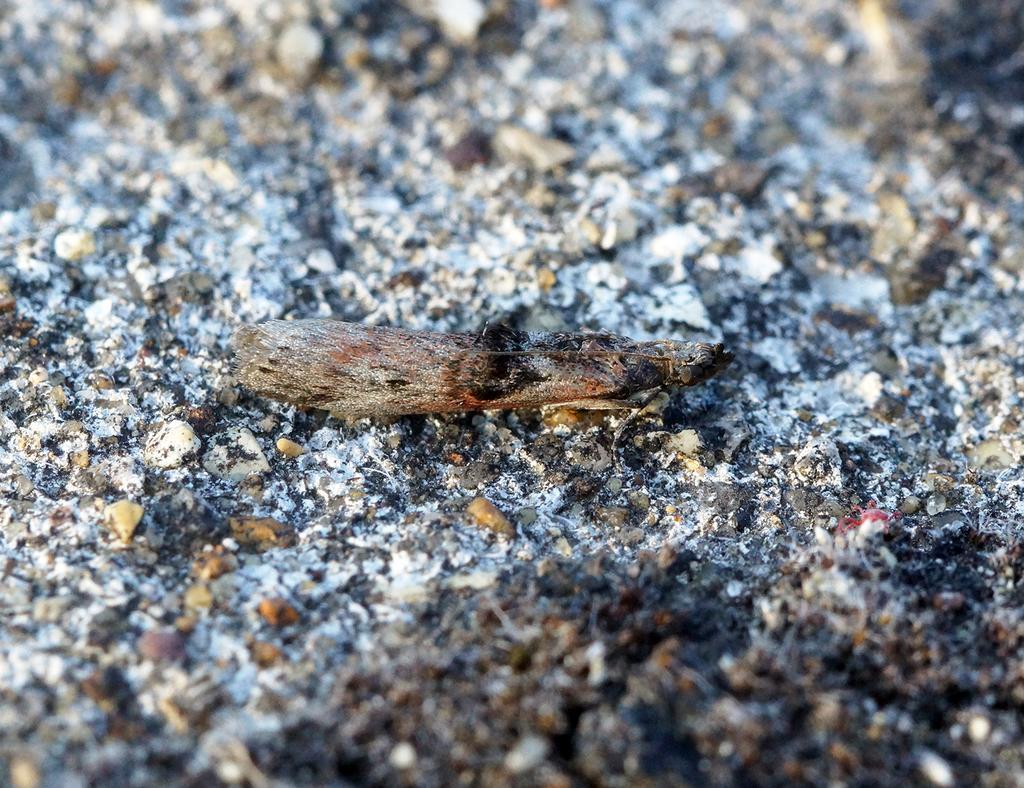How would you summarize this image in a sentence or two? In the image we can see a piece of wood, we can even see there are stones and ash. 